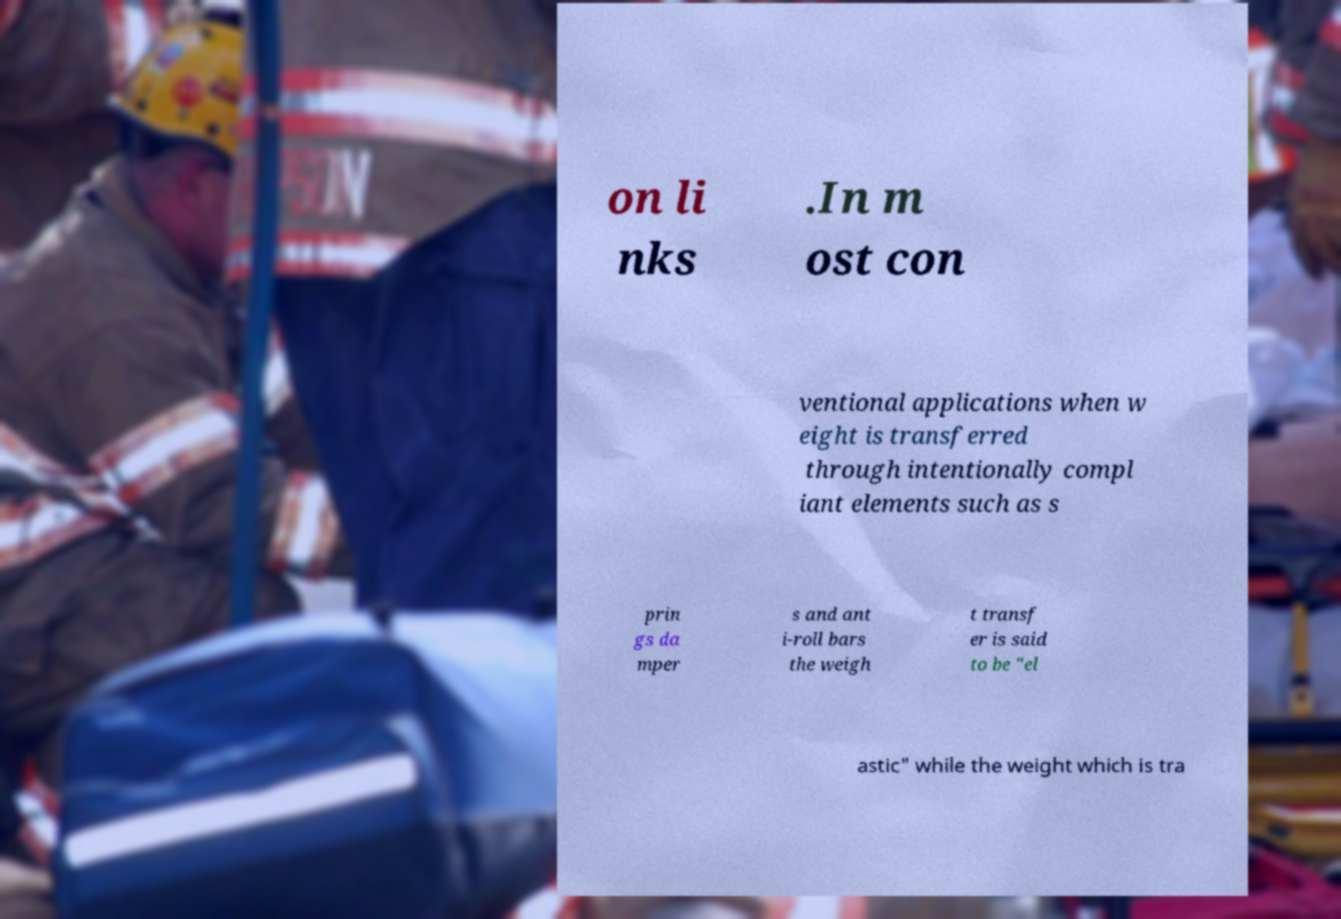Please read and relay the text visible in this image. What does it say? on li nks .In m ost con ventional applications when w eight is transferred through intentionally compl iant elements such as s prin gs da mper s and ant i-roll bars the weigh t transf er is said to be "el astic" while the weight which is tra 